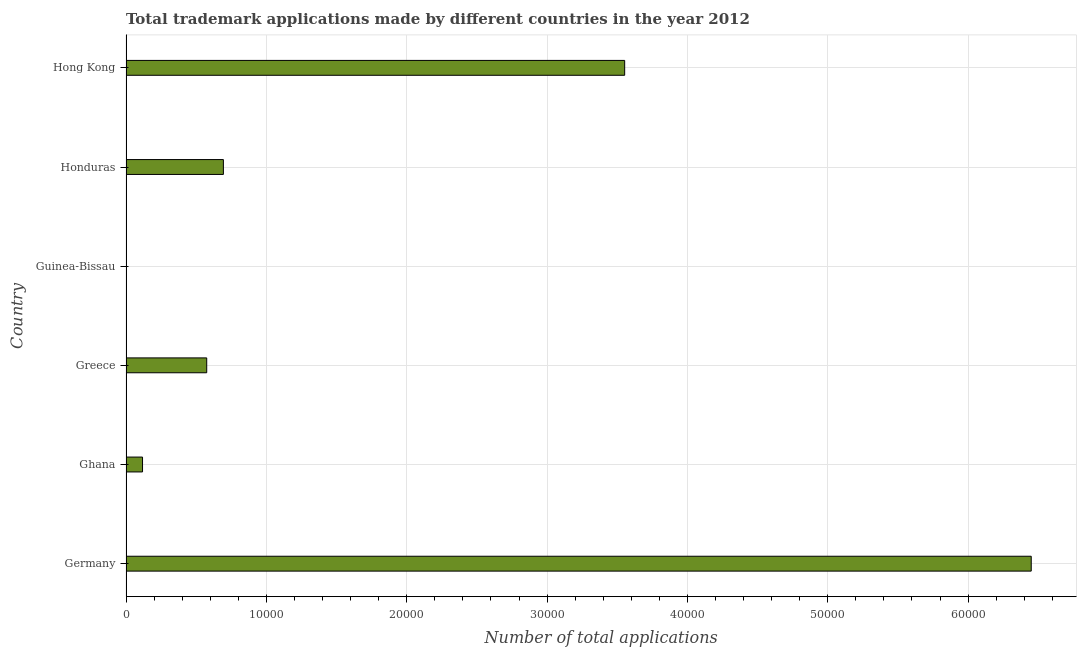What is the title of the graph?
Provide a succinct answer. Total trademark applications made by different countries in the year 2012. What is the label or title of the X-axis?
Provide a short and direct response. Number of total applications. What is the label or title of the Y-axis?
Give a very brief answer. Country. What is the number of trademark applications in Hong Kong?
Ensure brevity in your answer.  3.55e+04. Across all countries, what is the maximum number of trademark applications?
Your answer should be very brief. 6.45e+04. In which country was the number of trademark applications minimum?
Give a very brief answer. Guinea-Bissau. What is the sum of the number of trademark applications?
Your answer should be very brief. 1.14e+05. What is the difference between the number of trademark applications in Ghana and Greece?
Make the answer very short. -4573. What is the average number of trademark applications per country?
Offer a terse response. 1.90e+04. What is the median number of trademark applications?
Ensure brevity in your answer.  6344. What is the ratio of the number of trademark applications in Ghana to that in Guinea-Bissau?
Provide a succinct answer. 98.08. Is the number of trademark applications in Guinea-Bissau less than that in Honduras?
Provide a succinct answer. Yes. What is the difference between the highest and the second highest number of trademark applications?
Keep it short and to the point. 2.90e+04. What is the difference between the highest and the lowest number of trademark applications?
Offer a terse response. 6.45e+04. In how many countries, is the number of trademark applications greater than the average number of trademark applications taken over all countries?
Make the answer very short. 2. Are all the bars in the graph horizontal?
Your response must be concise. Yes. What is the Number of total applications in Germany?
Provide a short and direct response. 6.45e+04. What is the Number of total applications in Ghana?
Offer a very short reply. 1177. What is the Number of total applications of Greece?
Make the answer very short. 5750. What is the Number of total applications in Honduras?
Provide a short and direct response. 6938. What is the Number of total applications of Hong Kong?
Offer a terse response. 3.55e+04. What is the difference between the Number of total applications in Germany and Ghana?
Provide a short and direct response. 6.33e+04. What is the difference between the Number of total applications in Germany and Greece?
Your response must be concise. 5.87e+04. What is the difference between the Number of total applications in Germany and Guinea-Bissau?
Your answer should be very brief. 6.45e+04. What is the difference between the Number of total applications in Germany and Honduras?
Make the answer very short. 5.76e+04. What is the difference between the Number of total applications in Germany and Hong Kong?
Provide a succinct answer. 2.90e+04. What is the difference between the Number of total applications in Ghana and Greece?
Provide a short and direct response. -4573. What is the difference between the Number of total applications in Ghana and Guinea-Bissau?
Provide a short and direct response. 1165. What is the difference between the Number of total applications in Ghana and Honduras?
Provide a succinct answer. -5761. What is the difference between the Number of total applications in Ghana and Hong Kong?
Provide a short and direct response. -3.44e+04. What is the difference between the Number of total applications in Greece and Guinea-Bissau?
Offer a terse response. 5738. What is the difference between the Number of total applications in Greece and Honduras?
Offer a terse response. -1188. What is the difference between the Number of total applications in Greece and Hong Kong?
Your response must be concise. -2.98e+04. What is the difference between the Number of total applications in Guinea-Bissau and Honduras?
Ensure brevity in your answer.  -6926. What is the difference between the Number of total applications in Guinea-Bissau and Hong Kong?
Ensure brevity in your answer.  -3.55e+04. What is the difference between the Number of total applications in Honduras and Hong Kong?
Provide a succinct answer. -2.86e+04. What is the ratio of the Number of total applications in Germany to that in Ghana?
Your response must be concise. 54.8. What is the ratio of the Number of total applications in Germany to that in Greece?
Your answer should be compact. 11.22. What is the ratio of the Number of total applications in Germany to that in Guinea-Bissau?
Your answer should be very brief. 5374.75. What is the ratio of the Number of total applications in Germany to that in Honduras?
Provide a succinct answer. 9.3. What is the ratio of the Number of total applications in Germany to that in Hong Kong?
Your answer should be very brief. 1.81. What is the ratio of the Number of total applications in Ghana to that in Greece?
Offer a very short reply. 0.2. What is the ratio of the Number of total applications in Ghana to that in Guinea-Bissau?
Your response must be concise. 98.08. What is the ratio of the Number of total applications in Ghana to that in Honduras?
Your answer should be compact. 0.17. What is the ratio of the Number of total applications in Ghana to that in Hong Kong?
Your answer should be very brief. 0.03. What is the ratio of the Number of total applications in Greece to that in Guinea-Bissau?
Keep it short and to the point. 479.17. What is the ratio of the Number of total applications in Greece to that in Honduras?
Ensure brevity in your answer.  0.83. What is the ratio of the Number of total applications in Greece to that in Hong Kong?
Ensure brevity in your answer.  0.16. What is the ratio of the Number of total applications in Guinea-Bissau to that in Honduras?
Give a very brief answer. 0. What is the ratio of the Number of total applications in Guinea-Bissau to that in Hong Kong?
Provide a short and direct response. 0. What is the ratio of the Number of total applications in Honduras to that in Hong Kong?
Your answer should be very brief. 0.2. 